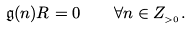Convert formula to latex. <formula><loc_0><loc_0><loc_500><loc_500>\mathfrak { g } ( n ) R = 0 \quad \forall n \in Z _ { _ { > 0 } } .</formula> 